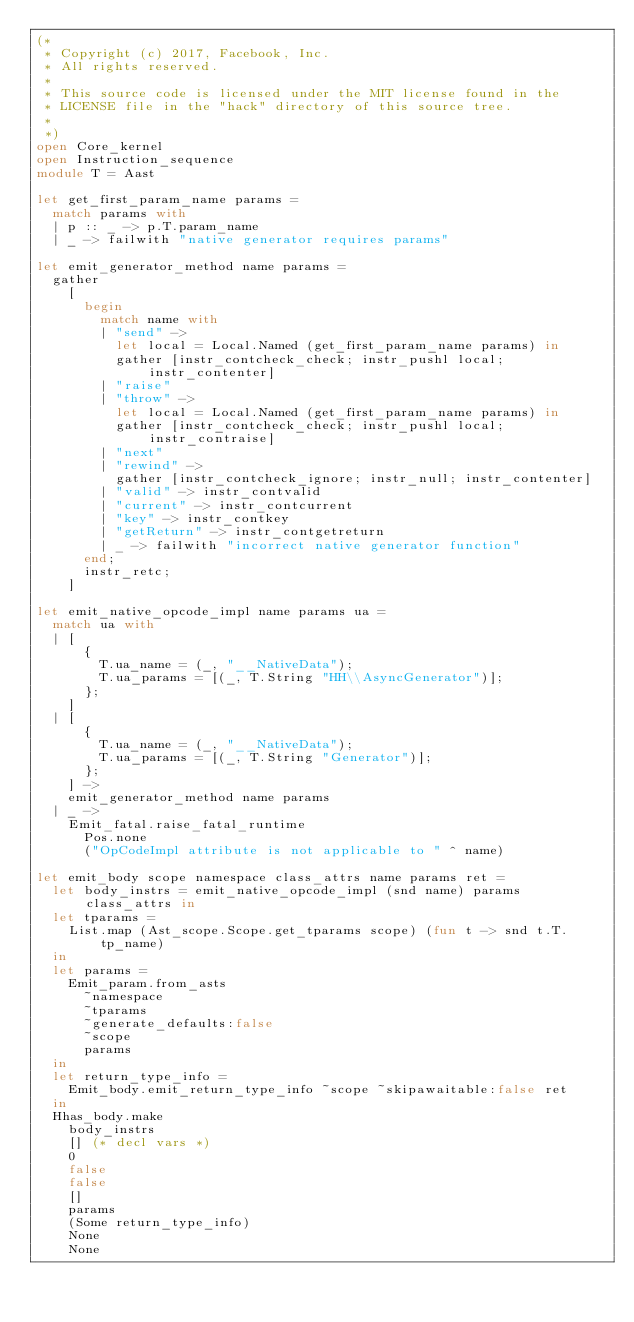Convert code to text. <code><loc_0><loc_0><loc_500><loc_500><_OCaml_>(*
 * Copyright (c) 2017, Facebook, Inc.
 * All rights reserved.
 *
 * This source code is licensed under the MIT license found in the
 * LICENSE file in the "hack" directory of this source tree.
 *
 *)
open Core_kernel
open Instruction_sequence
module T = Aast

let get_first_param_name params =
  match params with
  | p :: _ -> p.T.param_name
  | _ -> failwith "native generator requires params"

let emit_generator_method name params =
  gather
    [
      begin
        match name with
        | "send" ->
          let local = Local.Named (get_first_param_name params) in
          gather [instr_contcheck_check; instr_pushl local; instr_contenter]
        | "raise"
        | "throw" ->
          let local = Local.Named (get_first_param_name params) in
          gather [instr_contcheck_check; instr_pushl local; instr_contraise]
        | "next"
        | "rewind" ->
          gather [instr_contcheck_ignore; instr_null; instr_contenter]
        | "valid" -> instr_contvalid
        | "current" -> instr_contcurrent
        | "key" -> instr_contkey
        | "getReturn" -> instr_contgetreturn
        | _ -> failwith "incorrect native generator function"
      end;
      instr_retc;
    ]

let emit_native_opcode_impl name params ua =
  match ua with
  | [
      {
        T.ua_name = (_, "__NativeData");
        T.ua_params = [(_, T.String "HH\\AsyncGenerator")];
      };
    ]
  | [
      {
        T.ua_name = (_, "__NativeData");
        T.ua_params = [(_, T.String "Generator")];
      };
    ] ->
    emit_generator_method name params
  | _ ->
    Emit_fatal.raise_fatal_runtime
      Pos.none
      ("OpCodeImpl attribute is not applicable to " ^ name)

let emit_body scope namespace class_attrs name params ret =
  let body_instrs = emit_native_opcode_impl (snd name) params class_attrs in
  let tparams =
    List.map (Ast_scope.Scope.get_tparams scope) (fun t -> snd t.T.tp_name)
  in
  let params =
    Emit_param.from_asts
      ~namespace
      ~tparams
      ~generate_defaults:false
      ~scope
      params
  in
  let return_type_info =
    Emit_body.emit_return_type_info ~scope ~skipawaitable:false ret
  in
  Hhas_body.make
    body_instrs
    [] (* decl vars *)
    0
    false
    false
    []
    params
    (Some return_type_info)
    None
    None
</code> 